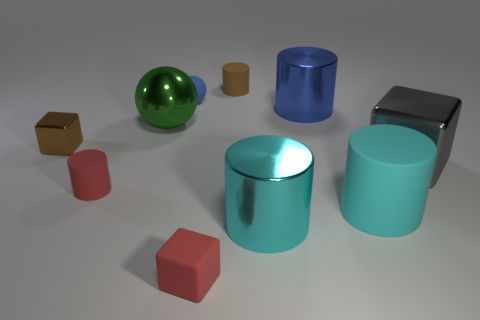What number of rubber things are small blocks or red blocks?
Offer a very short reply. 1. Is there a green metal object?
Your response must be concise. Yes. Is the shape of the big cyan rubber thing the same as the gray shiny object?
Your answer should be very brief. No. There is a matte object that is right of the large metal thing in front of the cyan rubber thing; how many blocks are left of it?
Give a very brief answer. 2. There is a small object that is right of the green metal thing and in front of the big gray metal object; what material is it made of?
Offer a very short reply. Rubber. There is a cube that is on the left side of the large gray metal block and behind the tiny red block; what is its color?
Provide a succinct answer. Brown. Are there any other things that are the same color as the small rubber sphere?
Your answer should be compact. Yes. There is a brown thing that is behind the tiny object left of the red thing behind the tiny red rubber block; what shape is it?
Make the answer very short. Cylinder. What color is the other large metal thing that is the same shape as the large blue thing?
Make the answer very short. Cyan. The big metal cylinder that is in front of the small red thing to the left of the small blue rubber thing is what color?
Offer a very short reply. Cyan. 